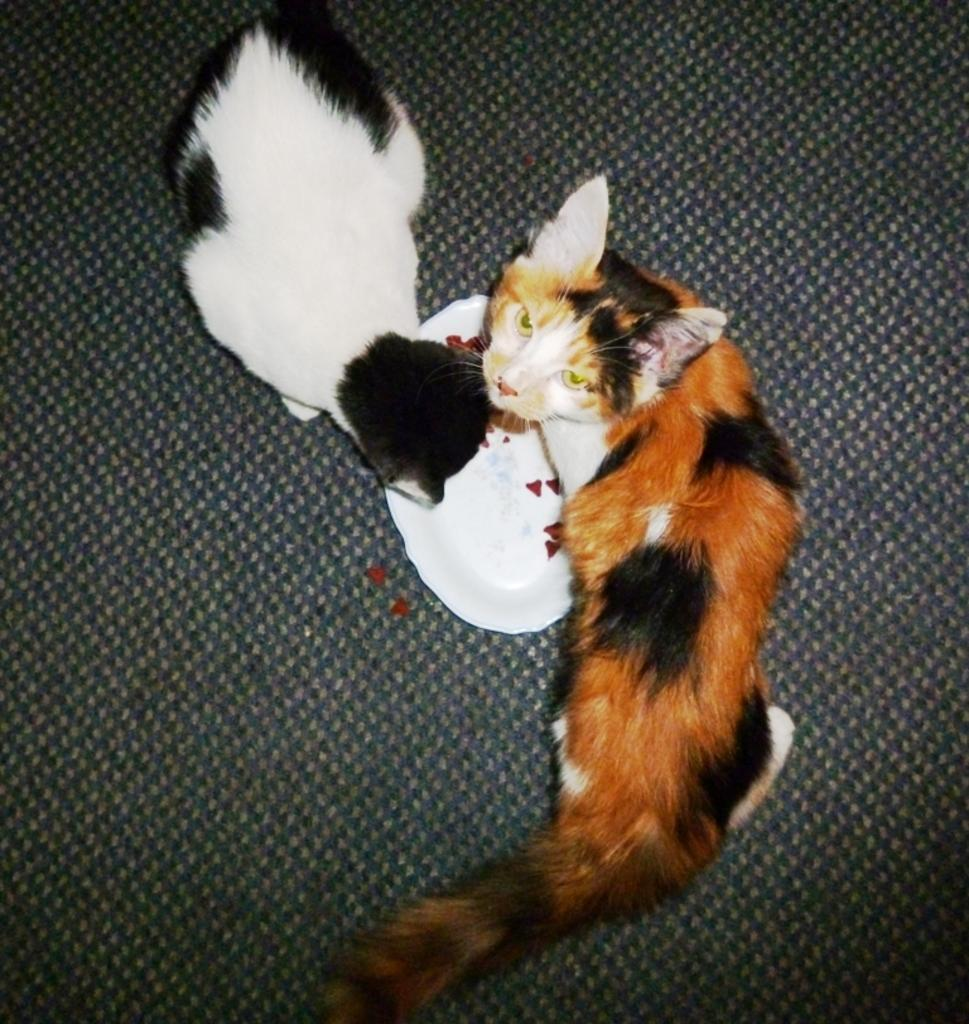How many cats are in the image? There are two cats in the image. What else can be seen in the image besides the cats? There is a plate in the image. Where is the plate located? The plate is on a path. What type of glue is being used to attach the cats to the plate in the image? There is no glue or attachment between the cats and the plate in the image; they are simply sitting near the plate. 